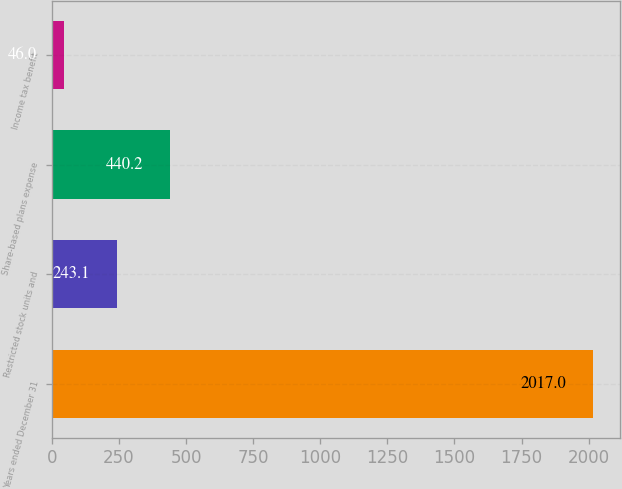Convert chart. <chart><loc_0><loc_0><loc_500><loc_500><bar_chart><fcel>Years ended December 31<fcel>Restricted stock units and<fcel>Share-based plans expense<fcel>Income tax benefit<nl><fcel>2017<fcel>243.1<fcel>440.2<fcel>46<nl></chart> 